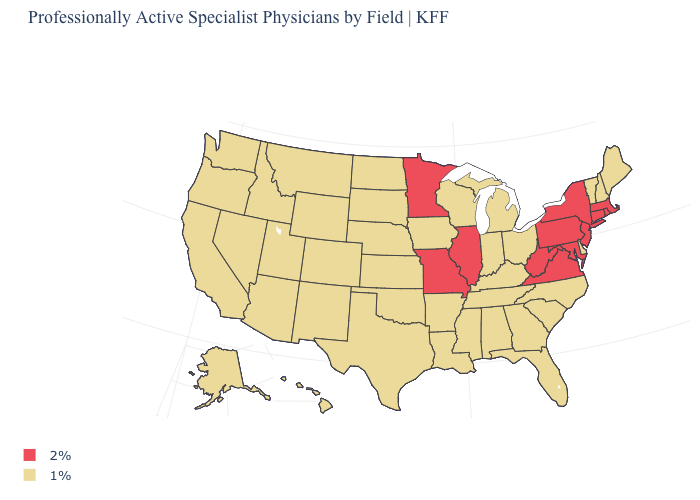Does Connecticut have a higher value than Maryland?
Concise answer only. No. What is the value of Virginia?
Be succinct. 2%. Does the first symbol in the legend represent the smallest category?
Keep it brief. No. What is the value of Maryland?
Answer briefly. 2%. Is the legend a continuous bar?
Give a very brief answer. No. Name the states that have a value in the range 2%?
Give a very brief answer. Connecticut, Illinois, Maryland, Massachusetts, Minnesota, Missouri, New Jersey, New York, Pennsylvania, Rhode Island, Virginia, West Virginia. Which states hav the highest value in the Northeast?
Keep it brief. Connecticut, Massachusetts, New Jersey, New York, Pennsylvania, Rhode Island. What is the value of West Virginia?
Answer briefly. 2%. Which states have the lowest value in the USA?
Concise answer only. Alabama, Alaska, Arizona, Arkansas, California, Colorado, Delaware, Florida, Georgia, Hawaii, Idaho, Indiana, Iowa, Kansas, Kentucky, Louisiana, Maine, Michigan, Mississippi, Montana, Nebraska, Nevada, New Hampshire, New Mexico, North Carolina, North Dakota, Ohio, Oklahoma, Oregon, South Carolina, South Dakota, Tennessee, Texas, Utah, Vermont, Washington, Wisconsin, Wyoming. Name the states that have a value in the range 1%?
Concise answer only. Alabama, Alaska, Arizona, Arkansas, California, Colorado, Delaware, Florida, Georgia, Hawaii, Idaho, Indiana, Iowa, Kansas, Kentucky, Louisiana, Maine, Michigan, Mississippi, Montana, Nebraska, Nevada, New Hampshire, New Mexico, North Carolina, North Dakota, Ohio, Oklahoma, Oregon, South Carolina, South Dakota, Tennessee, Texas, Utah, Vermont, Washington, Wisconsin, Wyoming. Which states have the highest value in the USA?
Give a very brief answer. Connecticut, Illinois, Maryland, Massachusetts, Minnesota, Missouri, New Jersey, New York, Pennsylvania, Rhode Island, Virginia, West Virginia. Which states hav the highest value in the West?
Quick response, please. Alaska, Arizona, California, Colorado, Hawaii, Idaho, Montana, Nevada, New Mexico, Oregon, Utah, Washington, Wyoming. What is the value of Arizona?
Short answer required. 1%. 